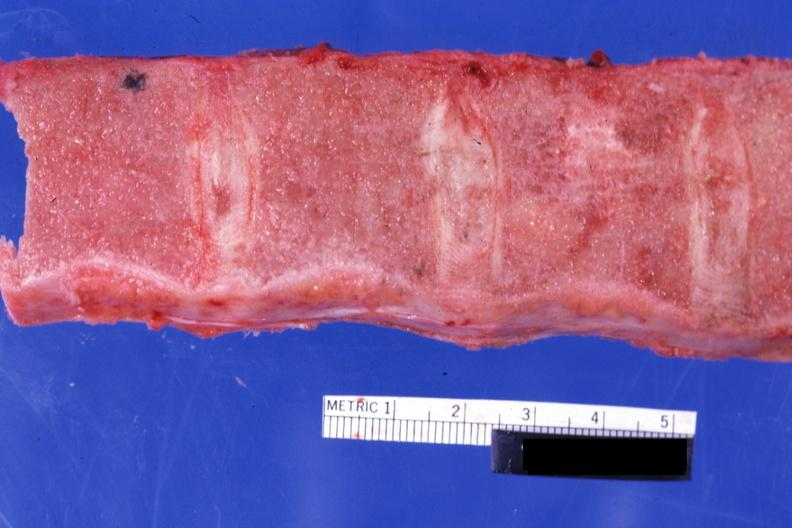s edema present?
Answer the question using a single word or phrase. No 